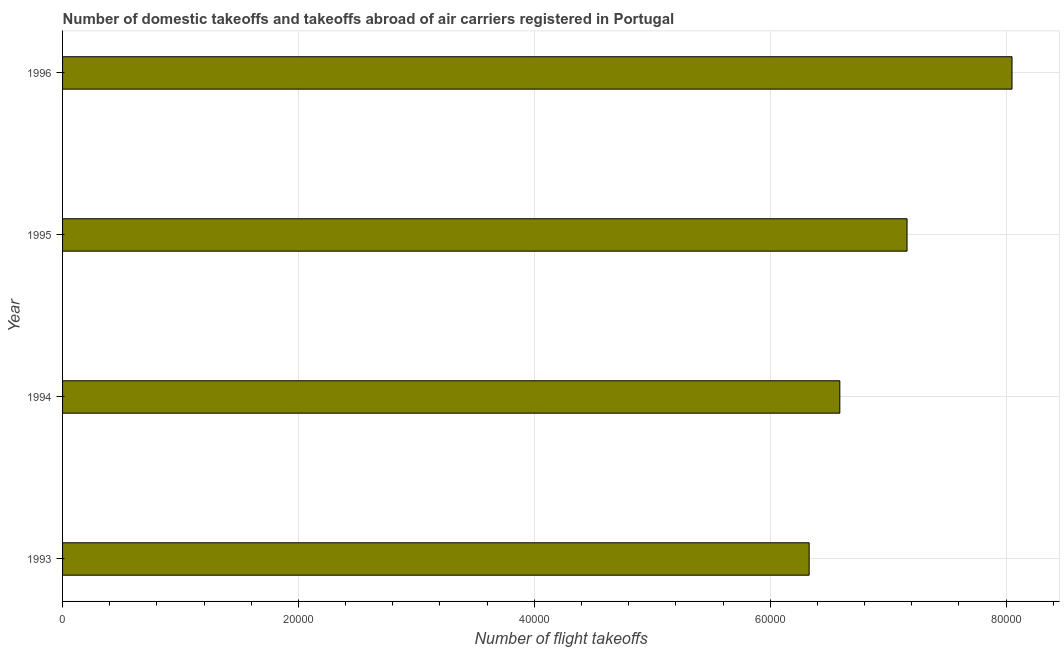Does the graph contain grids?
Provide a short and direct response. Yes. What is the title of the graph?
Your response must be concise. Number of domestic takeoffs and takeoffs abroad of air carriers registered in Portugal. What is the label or title of the X-axis?
Keep it short and to the point. Number of flight takeoffs. What is the label or title of the Y-axis?
Your answer should be very brief. Year. What is the number of flight takeoffs in 1993?
Give a very brief answer. 6.33e+04. Across all years, what is the maximum number of flight takeoffs?
Offer a terse response. 8.05e+04. Across all years, what is the minimum number of flight takeoffs?
Make the answer very short. 6.33e+04. In which year was the number of flight takeoffs maximum?
Your response must be concise. 1996. In which year was the number of flight takeoffs minimum?
Your response must be concise. 1993. What is the sum of the number of flight takeoffs?
Give a very brief answer. 2.81e+05. What is the difference between the number of flight takeoffs in 1993 and 1995?
Your response must be concise. -8300. What is the average number of flight takeoffs per year?
Offer a terse response. 7.03e+04. What is the median number of flight takeoffs?
Provide a short and direct response. 6.88e+04. In how many years, is the number of flight takeoffs greater than 72000 ?
Provide a succinct answer. 1. What is the ratio of the number of flight takeoffs in 1994 to that in 1996?
Your response must be concise. 0.82. Is the number of flight takeoffs in 1993 less than that in 1994?
Provide a succinct answer. Yes. Is the difference between the number of flight takeoffs in 1994 and 1995 greater than the difference between any two years?
Provide a succinct answer. No. What is the difference between the highest and the second highest number of flight takeoffs?
Offer a terse response. 8900. Is the sum of the number of flight takeoffs in 1995 and 1996 greater than the maximum number of flight takeoffs across all years?
Keep it short and to the point. Yes. What is the difference between the highest and the lowest number of flight takeoffs?
Give a very brief answer. 1.72e+04. In how many years, is the number of flight takeoffs greater than the average number of flight takeoffs taken over all years?
Offer a very short reply. 2. How many years are there in the graph?
Your answer should be very brief. 4. What is the difference between two consecutive major ticks on the X-axis?
Your response must be concise. 2.00e+04. Are the values on the major ticks of X-axis written in scientific E-notation?
Give a very brief answer. No. What is the Number of flight takeoffs of 1993?
Your answer should be compact. 6.33e+04. What is the Number of flight takeoffs in 1994?
Your answer should be very brief. 6.59e+04. What is the Number of flight takeoffs in 1995?
Provide a short and direct response. 7.16e+04. What is the Number of flight takeoffs in 1996?
Offer a very short reply. 8.05e+04. What is the difference between the Number of flight takeoffs in 1993 and 1994?
Offer a terse response. -2600. What is the difference between the Number of flight takeoffs in 1993 and 1995?
Offer a terse response. -8300. What is the difference between the Number of flight takeoffs in 1993 and 1996?
Your response must be concise. -1.72e+04. What is the difference between the Number of flight takeoffs in 1994 and 1995?
Your answer should be compact. -5700. What is the difference between the Number of flight takeoffs in 1994 and 1996?
Your answer should be compact. -1.46e+04. What is the difference between the Number of flight takeoffs in 1995 and 1996?
Make the answer very short. -8900. What is the ratio of the Number of flight takeoffs in 1993 to that in 1994?
Offer a very short reply. 0.96. What is the ratio of the Number of flight takeoffs in 1993 to that in 1995?
Offer a very short reply. 0.88. What is the ratio of the Number of flight takeoffs in 1993 to that in 1996?
Your answer should be very brief. 0.79. What is the ratio of the Number of flight takeoffs in 1994 to that in 1995?
Provide a short and direct response. 0.92. What is the ratio of the Number of flight takeoffs in 1994 to that in 1996?
Offer a terse response. 0.82. What is the ratio of the Number of flight takeoffs in 1995 to that in 1996?
Provide a short and direct response. 0.89. 